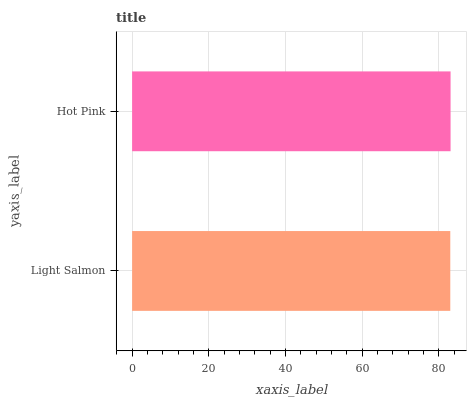Is Light Salmon the minimum?
Answer yes or no. Yes. Is Hot Pink the maximum?
Answer yes or no. Yes. Is Hot Pink the minimum?
Answer yes or no. No. Is Hot Pink greater than Light Salmon?
Answer yes or no. Yes. Is Light Salmon less than Hot Pink?
Answer yes or no. Yes. Is Light Salmon greater than Hot Pink?
Answer yes or no. No. Is Hot Pink less than Light Salmon?
Answer yes or no. No. Is Hot Pink the high median?
Answer yes or no. Yes. Is Light Salmon the low median?
Answer yes or no. Yes. Is Light Salmon the high median?
Answer yes or no. No. Is Hot Pink the low median?
Answer yes or no. No. 